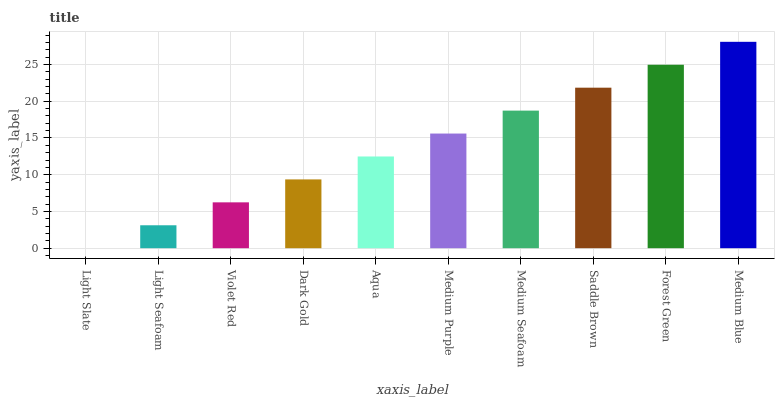Is Light Slate the minimum?
Answer yes or no. Yes. Is Medium Blue the maximum?
Answer yes or no. Yes. Is Light Seafoam the minimum?
Answer yes or no. No. Is Light Seafoam the maximum?
Answer yes or no. No. Is Light Seafoam greater than Light Slate?
Answer yes or no. Yes. Is Light Slate less than Light Seafoam?
Answer yes or no. Yes. Is Light Slate greater than Light Seafoam?
Answer yes or no. No. Is Light Seafoam less than Light Slate?
Answer yes or no. No. Is Medium Purple the high median?
Answer yes or no. Yes. Is Aqua the low median?
Answer yes or no. Yes. Is Violet Red the high median?
Answer yes or no. No. Is Medium Seafoam the low median?
Answer yes or no. No. 